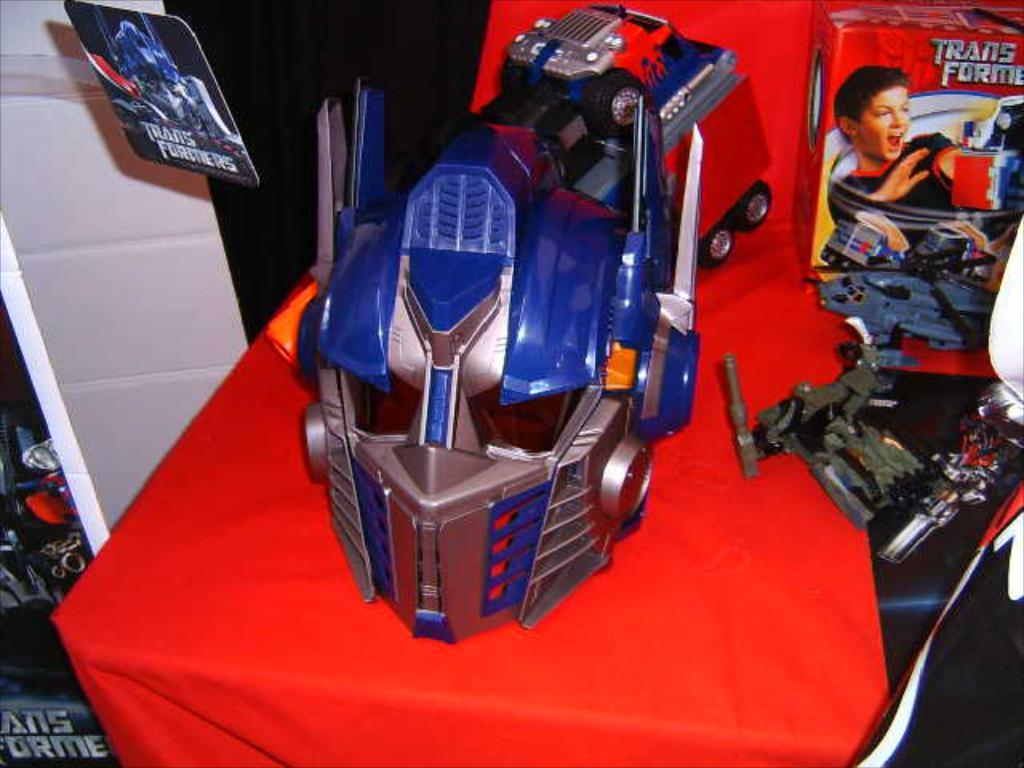<image>
Create a compact narrative representing the image presented. a TRANSFORMERS toy and box on display on a red cloth. 